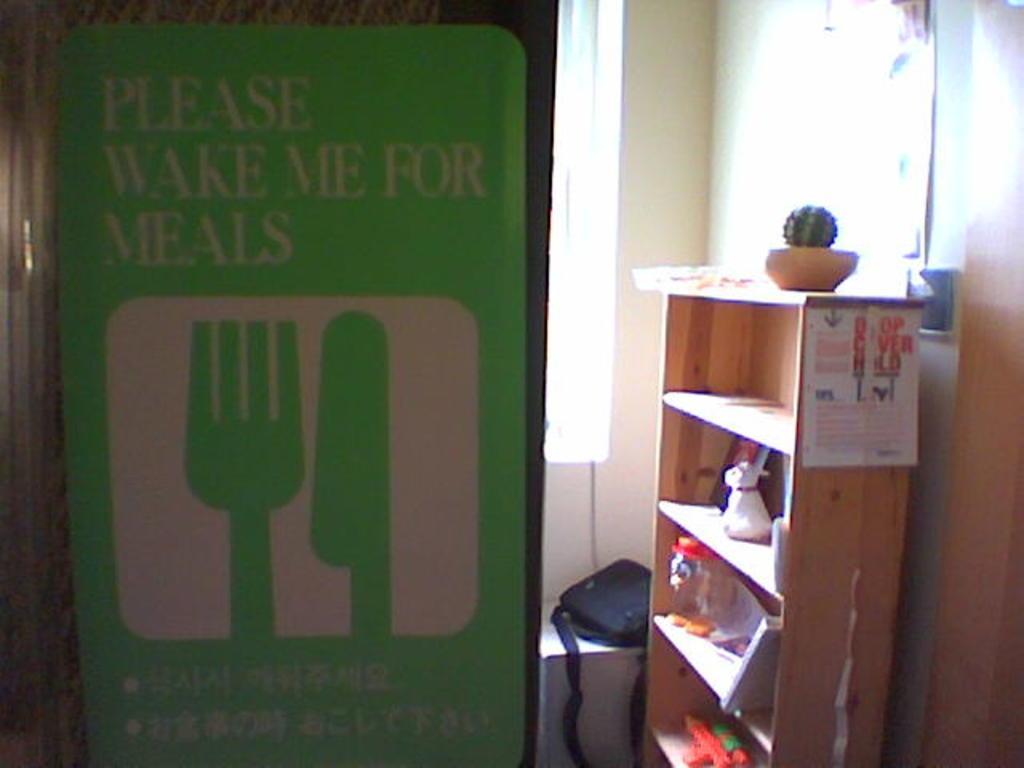In one or two sentences, can you explain what this image depicts? In this picture I can observe a green color board fixed to the wall. There is text on the board. On the right side I can observe a shelf. There is a black color bag beside the shelf. In the background there is a wall. 